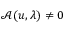Convert formula to latex. <formula><loc_0><loc_0><loc_500><loc_500>\mathcal { A } ( u , \lambda ) \neq 0</formula> 